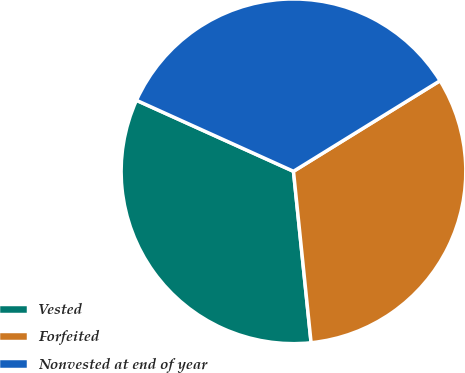Convert chart to OTSL. <chart><loc_0><loc_0><loc_500><loc_500><pie_chart><fcel>Vested<fcel>Forfeited<fcel>Nonvested at end of year<nl><fcel>33.39%<fcel>32.18%<fcel>34.43%<nl></chart> 